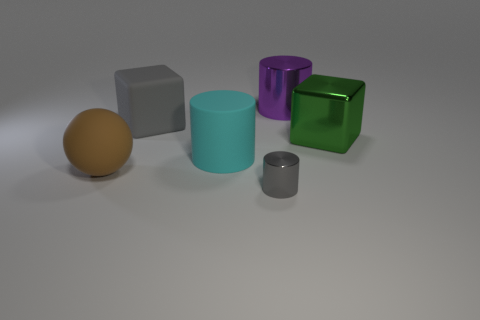Add 1 metallic objects. How many objects exist? 7 Subtract all blocks. How many objects are left? 4 Add 1 gray rubber objects. How many gray rubber objects exist? 2 Subtract 0 yellow blocks. How many objects are left? 6 Subtract all gray rubber things. Subtract all gray shiny things. How many objects are left? 4 Add 1 matte blocks. How many matte blocks are left? 2 